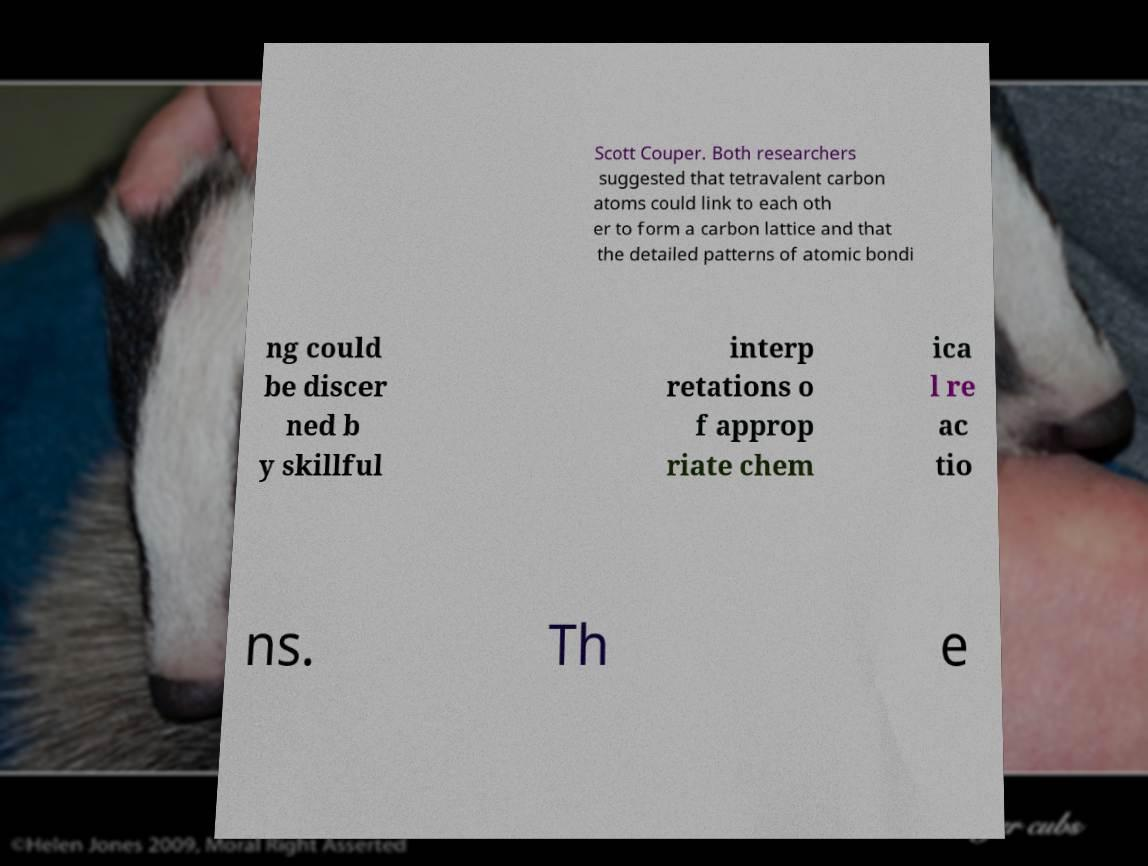Could you assist in decoding the text presented in this image and type it out clearly? Scott Couper. Both researchers suggested that tetravalent carbon atoms could link to each oth er to form a carbon lattice and that the detailed patterns of atomic bondi ng could be discer ned b y skillful interp retations o f approp riate chem ica l re ac tio ns. Th e 